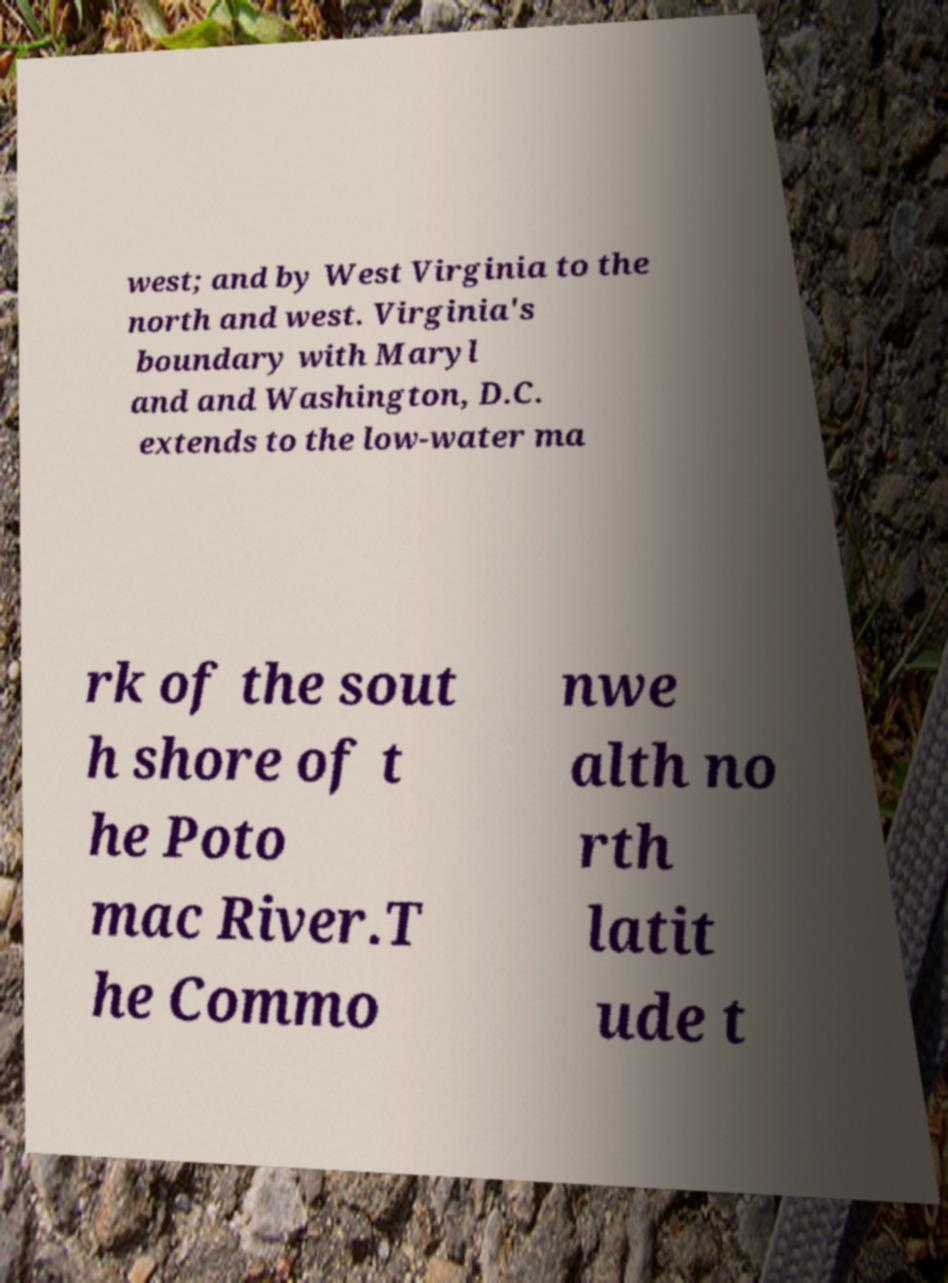Please identify and transcribe the text found in this image. west; and by West Virginia to the north and west. Virginia's boundary with Maryl and and Washington, D.C. extends to the low-water ma rk of the sout h shore of t he Poto mac River.T he Commo nwe alth no rth latit ude t 